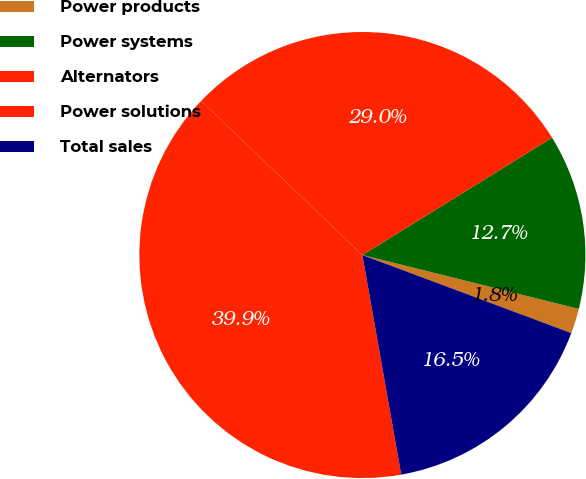Convert chart to OTSL. <chart><loc_0><loc_0><loc_500><loc_500><pie_chart><fcel>Power products<fcel>Power systems<fcel>Alternators<fcel>Power solutions<fcel>Total sales<nl><fcel>1.81%<fcel>12.7%<fcel>29.04%<fcel>39.93%<fcel>16.52%<nl></chart> 